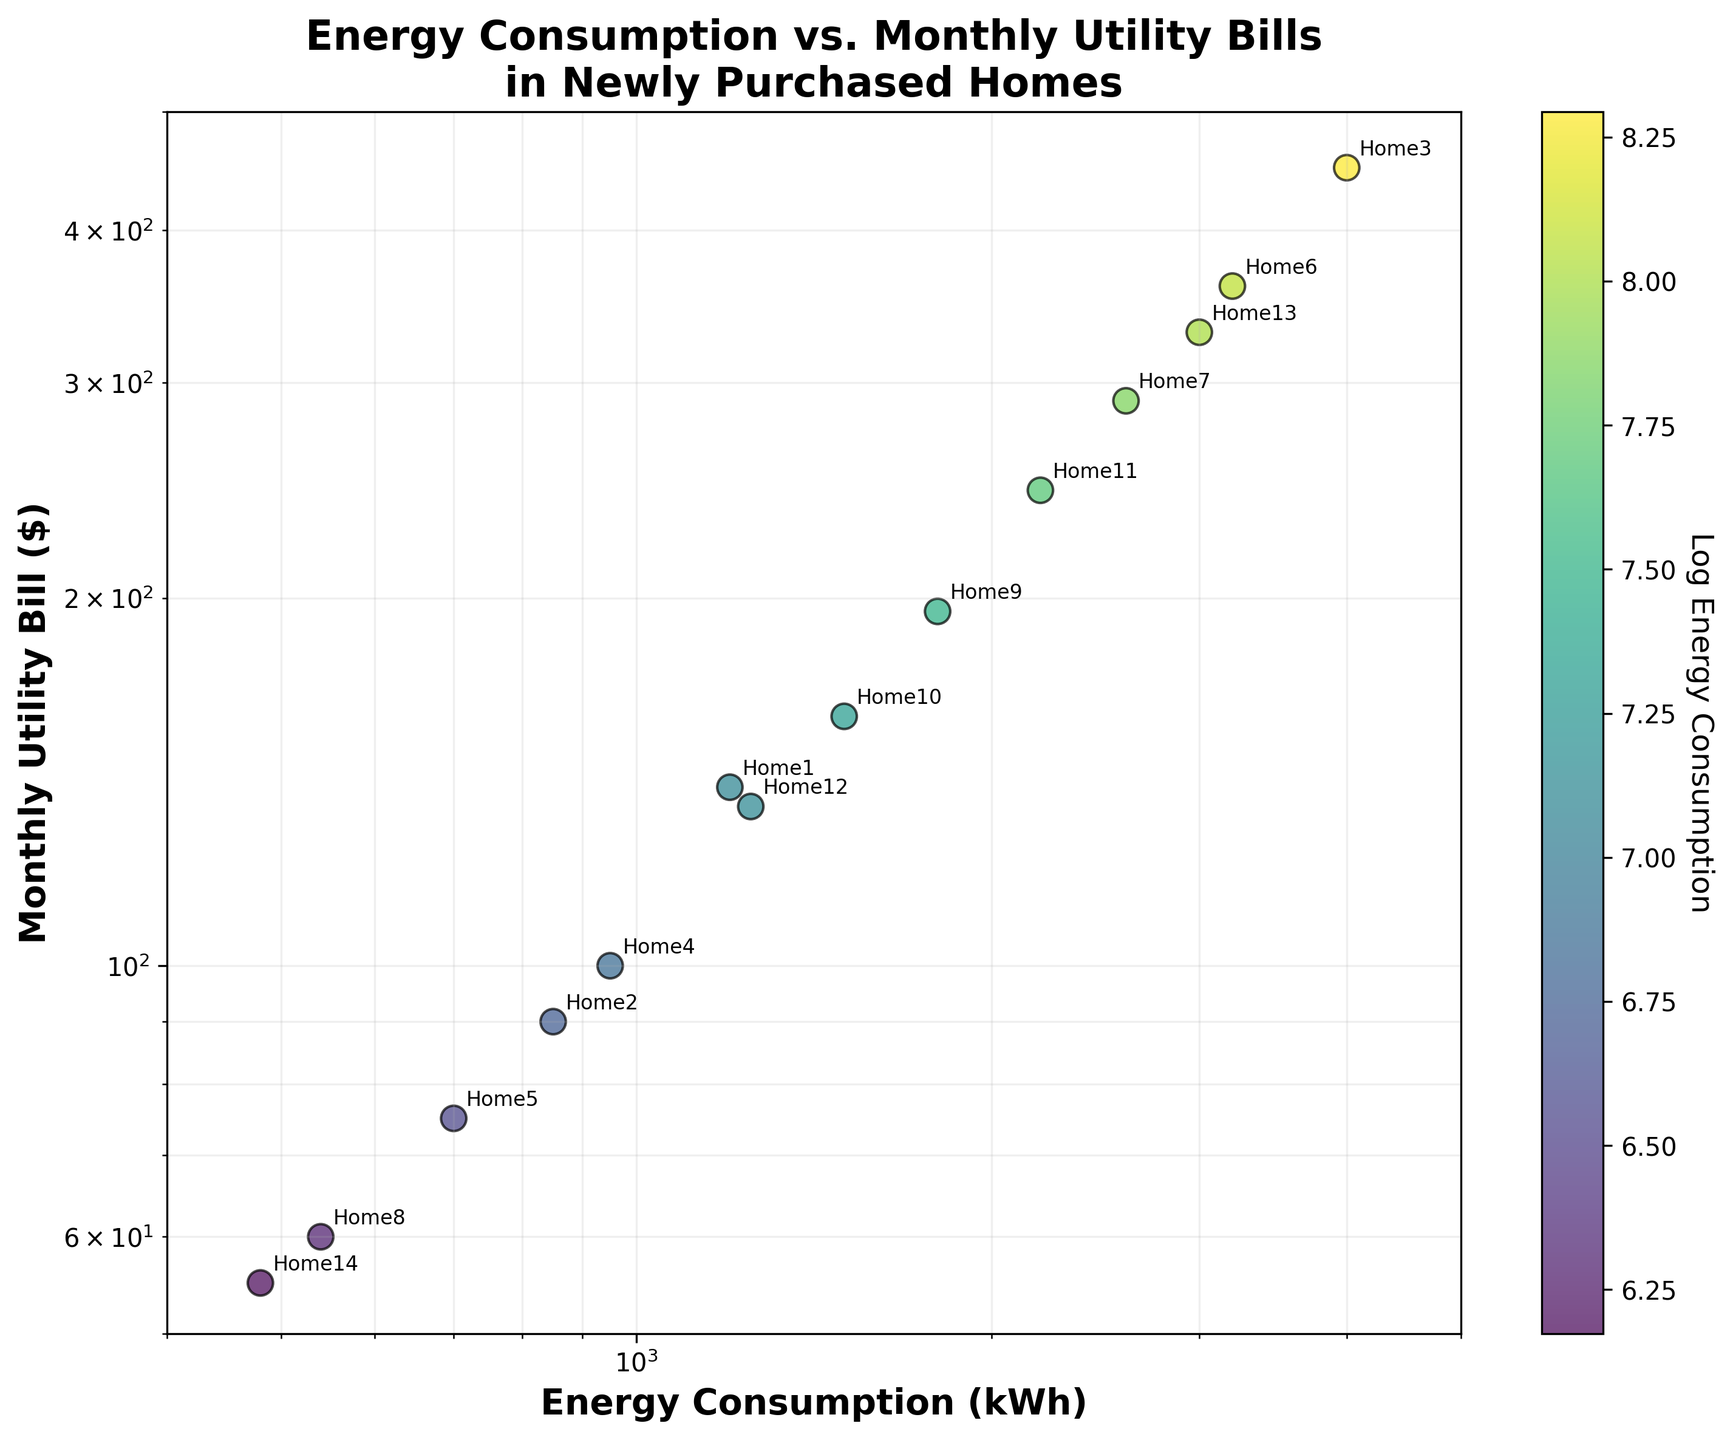What's the title of the figure? The title is usually located at the top of the plot. It introduces the central theme of the plot, which in this case is "Energy Consumption vs. Monthly Utility Bills in Newly Purchased Homes".
Answer: Energy Consumption vs. Monthly Utility Bills in Newly Purchased Homes What is the scale type used for the x-axis? The x-axis displays the energy consumption in kWh, and since it's mentioned in the problem statement, it uses a logarithmic scale.
Answer: Logarithmic What home has the highest energy consumption? By looking at the scatter plot and identifying the dot farthest to the right along the x-axis, which represents energy consumption, we find that Home3 has the highest kWh.
Answer: Home3 What's the range of the y-axis values? The y-axis represents the monthly utility bills in dollars. By examining the axis and the annotations, the range goes from around 50 to approximately 500.
Answer: 50 to 500 Which homes have energy consumption below 1000 kWh? By identifying the dots on the scatter plot with x-values less than 1000 kWh, we can see that Home2, Home4, Home5, Home8, and Home14 fall within this range.
Answer: Home2, Home4, Home5, Home8, Home14 Which home has the largest monthly utility bill and what is the value? To find the largest utility bill, locate the data point highest on the y-axis and note the corresponding home. This point is labeled as Home3.
Answer: Home3, $450 How is the relationship between energy consumption and monthly utility bills visualized in the plot? The scatter plot depicts each home as a dot, with energy consumption kWh on the x-axis and monthly utility bills in dollars on the y-axis, both on a logarithmic scale. The color gradient based on the log of energy consumption also aids in visualizing the relationship.
Answer: Using logarithmic scales and color gradients Which home has the most significant difference between energy consumption and monthly utility bill? By comparing the relative positions of each home in terms of distance on the scatter plot, Home3 stands out with a very high energy consumption and a correspondingly high utility bill, indicating a significant difference.
Answer: Home3 What is the average monthly utility bill of homes with energy consumption above 2000 kWh? Identify the homes whose x-values exceed 2000 kWh (Home3, Home6, Home7, Home11, Home13) and compute the average of their y-values: (450 + 360 + 290 + 245 + 330)/5 = 335.
Answer: $335 